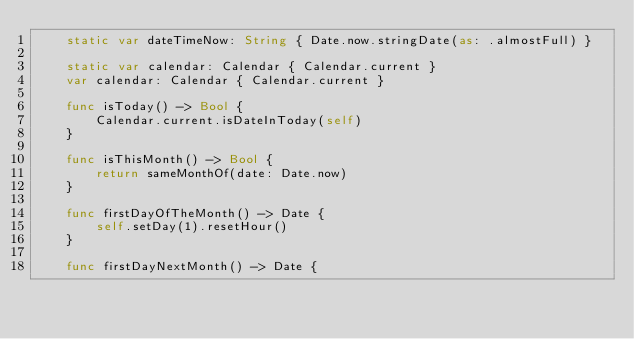Convert code to text. <code><loc_0><loc_0><loc_500><loc_500><_Swift_>    static var dateTimeNow: String { Date.now.stringDate(as: .almostFull) }
    
    static var calendar: Calendar { Calendar.current }
    var calendar: Calendar { Calendar.current }
    
    func isToday() -> Bool {
        Calendar.current.isDateInToday(self)
    }
    
    func isThisMonth() -> Bool {
        return sameMonthOf(date: Date.now)
    }
    
    func firstDayOfTheMonth() -> Date {
        self.setDay(1).resetHour()
    }
    
    func firstDayNextMonth() -> Date {</code> 